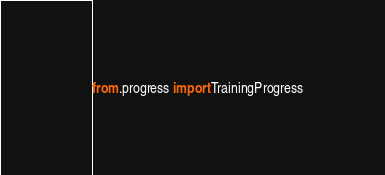Convert code to text. <code><loc_0><loc_0><loc_500><loc_500><_Python_>from .progress import TrainingProgress</code> 